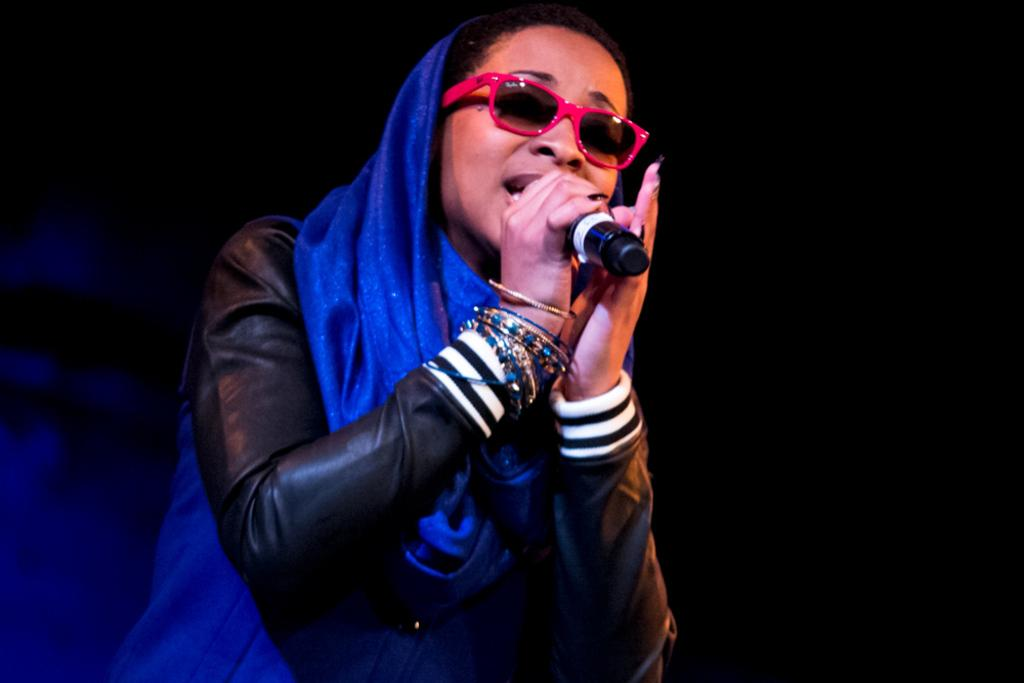Who is the main subject in the image? There is a woman in the image. What is the woman wearing on her face? The woman is wearing spectacles. What color is the saree that the woman is wearing? The woman is wearing a blue color saree. What is the woman holding in her hand? The woman is holding a mic. How many times has the woman folded the dust in the image? There is no dust or folding action present in the image. 